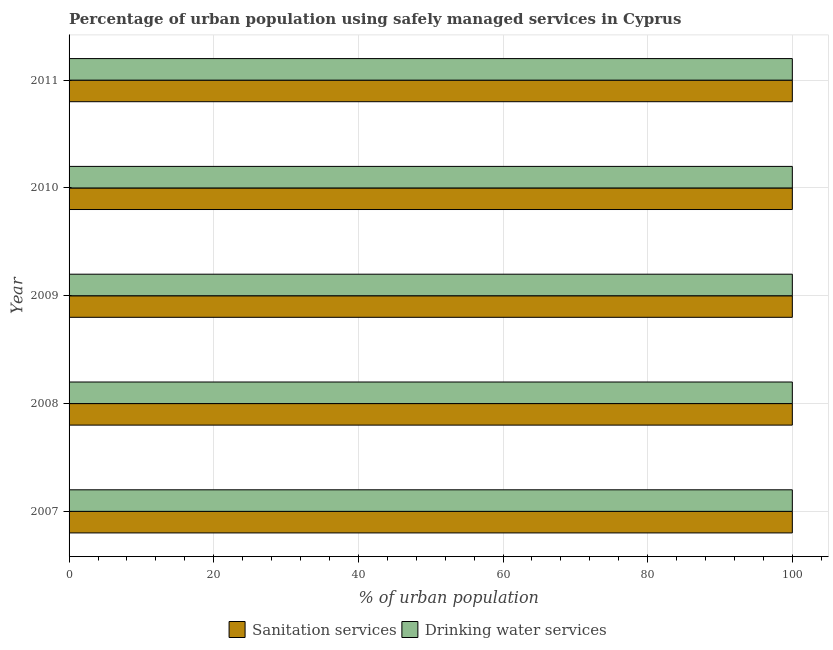How many different coloured bars are there?
Ensure brevity in your answer.  2. Are the number of bars per tick equal to the number of legend labels?
Give a very brief answer. Yes. How many bars are there on the 5th tick from the top?
Provide a succinct answer. 2. How many bars are there on the 4th tick from the bottom?
Your answer should be very brief. 2. What is the label of the 4th group of bars from the top?
Your response must be concise. 2008. What is the percentage of urban population who used drinking water services in 2011?
Your answer should be very brief. 100. Across all years, what is the maximum percentage of urban population who used drinking water services?
Offer a very short reply. 100. Across all years, what is the minimum percentage of urban population who used drinking water services?
Your answer should be very brief. 100. In which year was the percentage of urban population who used drinking water services maximum?
Provide a succinct answer. 2007. What is the total percentage of urban population who used sanitation services in the graph?
Provide a succinct answer. 500. What is the average percentage of urban population who used drinking water services per year?
Your answer should be compact. 100. In the year 2010, what is the difference between the percentage of urban population who used drinking water services and percentage of urban population who used sanitation services?
Offer a very short reply. 0. In how many years, is the percentage of urban population who used drinking water services greater than 36 %?
Your answer should be compact. 5. Is the percentage of urban population who used sanitation services in 2007 less than that in 2008?
Your answer should be compact. No. What is the difference between the highest and the second highest percentage of urban population who used sanitation services?
Give a very brief answer. 0. What is the difference between the highest and the lowest percentage of urban population who used drinking water services?
Make the answer very short. 0. In how many years, is the percentage of urban population who used sanitation services greater than the average percentage of urban population who used sanitation services taken over all years?
Keep it short and to the point. 0. What does the 2nd bar from the top in 2007 represents?
Make the answer very short. Sanitation services. What does the 1st bar from the bottom in 2008 represents?
Keep it short and to the point. Sanitation services. What is the difference between two consecutive major ticks on the X-axis?
Make the answer very short. 20. Are the values on the major ticks of X-axis written in scientific E-notation?
Offer a very short reply. No. What is the title of the graph?
Ensure brevity in your answer.  Percentage of urban population using safely managed services in Cyprus. Does "Young" appear as one of the legend labels in the graph?
Keep it short and to the point. No. What is the label or title of the X-axis?
Your answer should be compact. % of urban population. What is the label or title of the Y-axis?
Keep it short and to the point. Year. What is the % of urban population in Sanitation services in 2007?
Offer a very short reply. 100. What is the % of urban population in Drinking water services in 2007?
Your answer should be compact. 100. What is the % of urban population of Drinking water services in 2009?
Keep it short and to the point. 100. What is the % of urban population of Sanitation services in 2010?
Make the answer very short. 100. What is the % of urban population of Sanitation services in 2011?
Ensure brevity in your answer.  100. Across all years, what is the maximum % of urban population of Sanitation services?
Make the answer very short. 100. Across all years, what is the minimum % of urban population in Sanitation services?
Your answer should be very brief. 100. Across all years, what is the minimum % of urban population in Drinking water services?
Provide a short and direct response. 100. What is the total % of urban population of Sanitation services in the graph?
Keep it short and to the point. 500. What is the total % of urban population of Drinking water services in the graph?
Offer a very short reply. 500. What is the difference between the % of urban population in Sanitation services in 2007 and that in 2008?
Keep it short and to the point. 0. What is the difference between the % of urban population in Drinking water services in 2007 and that in 2008?
Ensure brevity in your answer.  0. What is the difference between the % of urban population of Sanitation services in 2007 and that in 2010?
Your response must be concise. 0. What is the difference between the % of urban population of Drinking water services in 2007 and that in 2010?
Offer a very short reply. 0. What is the difference between the % of urban population of Sanitation services in 2007 and that in 2011?
Provide a short and direct response. 0. What is the difference between the % of urban population in Drinking water services in 2007 and that in 2011?
Give a very brief answer. 0. What is the difference between the % of urban population in Drinking water services in 2008 and that in 2009?
Provide a short and direct response. 0. What is the difference between the % of urban population of Drinking water services in 2008 and that in 2011?
Your answer should be compact. 0. What is the difference between the % of urban population in Sanitation services in 2009 and that in 2011?
Provide a succinct answer. 0. What is the difference between the % of urban population in Drinking water services in 2010 and that in 2011?
Offer a very short reply. 0. What is the difference between the % of urban population of Sanitation services in 2007 and the % of urban population of Drinking water services in 2009?
Offer a terse response. 0. What is the difference between the % of urban population of Sanitation services in 2007 and the % of urban population of Drinking water services in 2011?
Offer a very short reply. 0. What is the difference between the % of urban population in Sanitation services in 2008 and the % of urban population in Drinking water services in 2010?
Your response must be concise. 0. What is the average % of urban population of Sanitation services per year?
Make the answer very short. 100. In the year 2010, what is the difference between the % of urban population in Sanitation services and % of urban population in Drinking water services?
Make the answer very short. 0. In the year 2011, what is the difference between the % of urban population of Sanitation services and % of urban population of Drinking water services?
Offer a very short reply. 0. What is the ratio of the % of urban population in Sanitation services in 2007 to that in 2008?
Offer a very short reply. 1. What is the ratio of the % of urban population of Sanitation services in 2007 to that in 2009?
Ensure brevity in your answer.  1. What is the ratio of the % of urban population of Drinking water services in 2007 to that in 2009?
Provide a succinct answer. 1. What is the ratio of the % of urban population in Drinking water services in 2007 to that in 2010?
Offer a very short reply. 1. What is the ratio of the % of urban population in Sanitation services in 2007 to that in 2011?
Make the answer very short. 1. What is the ratio of the % of urban population in Drinking water services in 2008 to that in 2010?
Provide a short and direct response. 1. What is the ratio of the % of urban population of Sanitation services in 2008 to that in 2011?
Make the answer very short. 1. What is the ratio of the % of urban population in Drinking water services in 2008 to that in 2011?
Provide a succinct answer. 1. What is the ratio of the % of urban population of Drinking water services in 2009 to that in 2010?
Offer a very short reply. 1. What is the ratio of the % of urban population in Sanitation services in 2009 to that in 2011?
Your answer should be compact. 1. What is the difference between the highest and the lowest % of urban population of Sanitation services?
Provide a short and direct response. 0. 